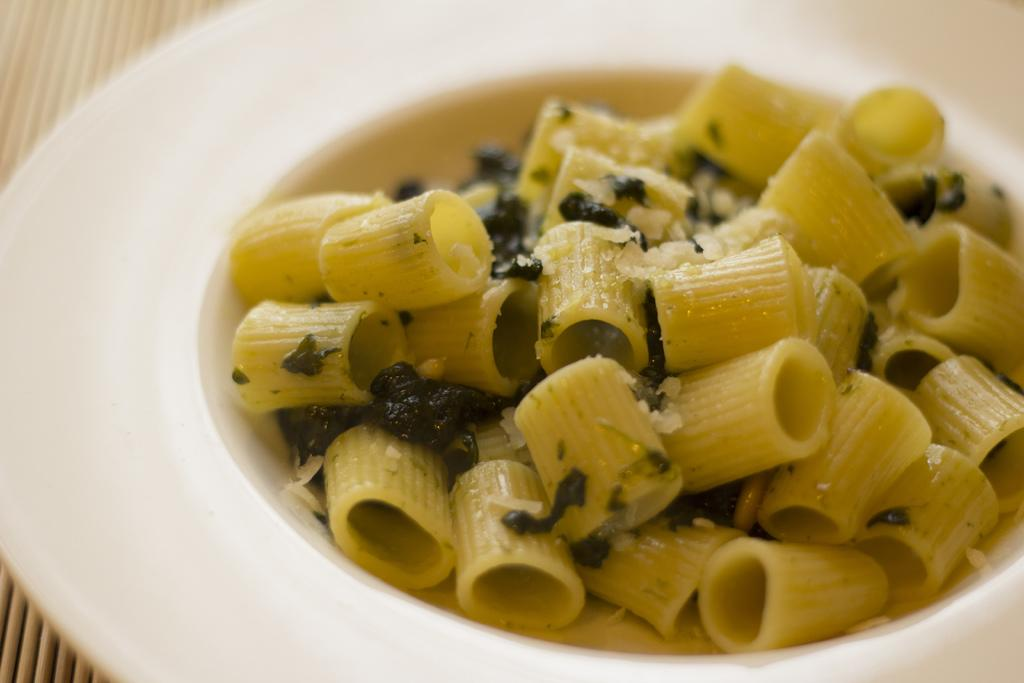What is on the plate in the image? There is a bowl on the plate. What is inside the bowl on the plate? There is pasta on the plate. What can be seen in the pasta? There are green leaves in the pasta. What type of pets are visible in the image? There are no pets visible in the image. What is the temper of the pasta in the image? The temper of the pasta cannot be determined from the image, as pasta does not have emotions or a temperament. 